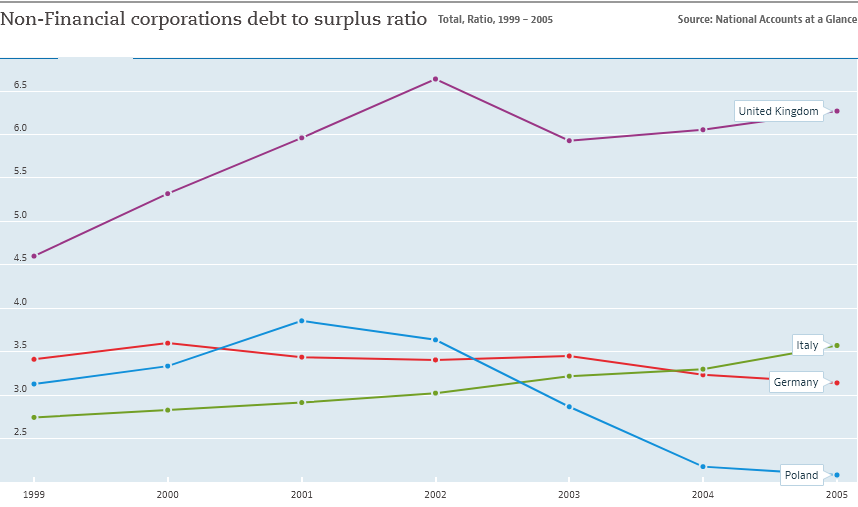Mention a couple of crucial points in this snapshot. Over the years, the non-financial corporations debt to surplus ratio in the United Kingdom has been higher than that of Italy. In 2005, the debt-to-surplus ratio for non-financial corporations in Poland reached its lowest point over the years. 